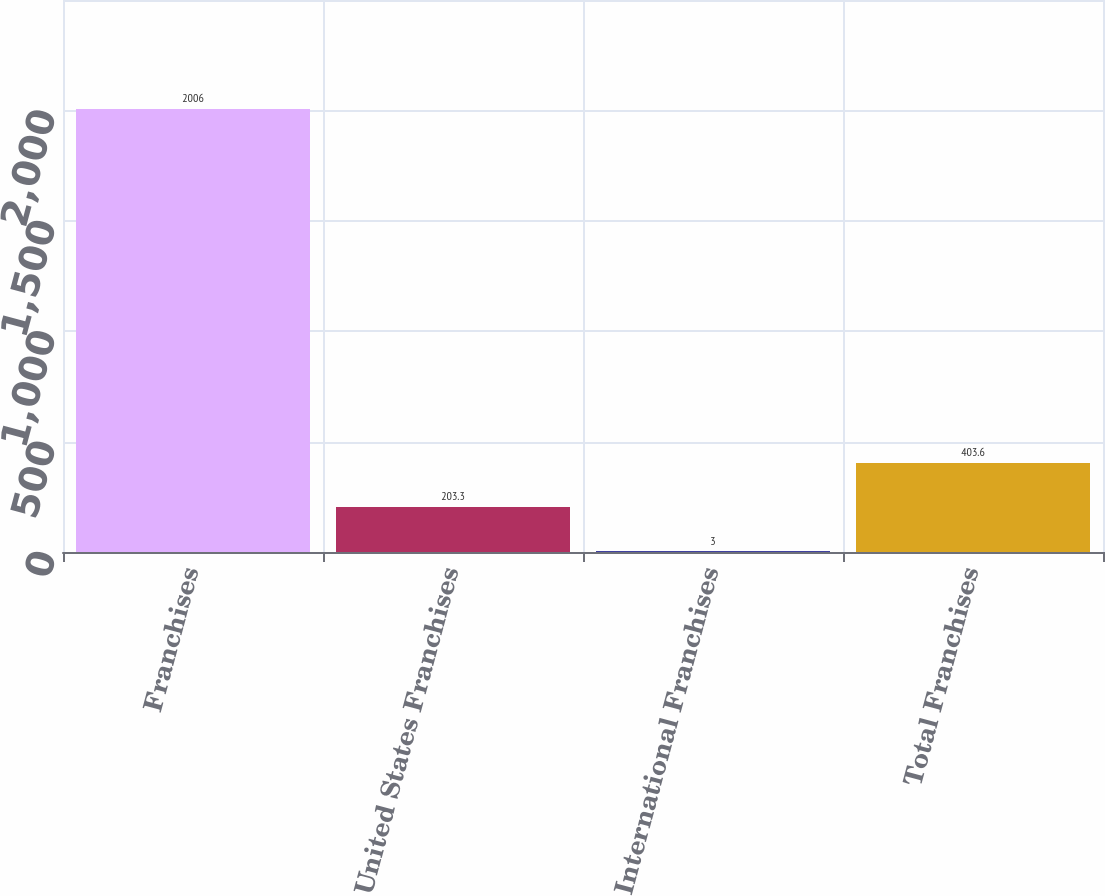Convert chart to OTSL. <chart><loc_0><loc_0><loc_500><loc_500><bar_chart><fcel>Franchises<fcel>United States Franchises<fcel>International Franchises<fcel>Total Franchises<nl><fcel>2006<fcel>203.3<fcel>3<fcel>403.6<nl></chart> 